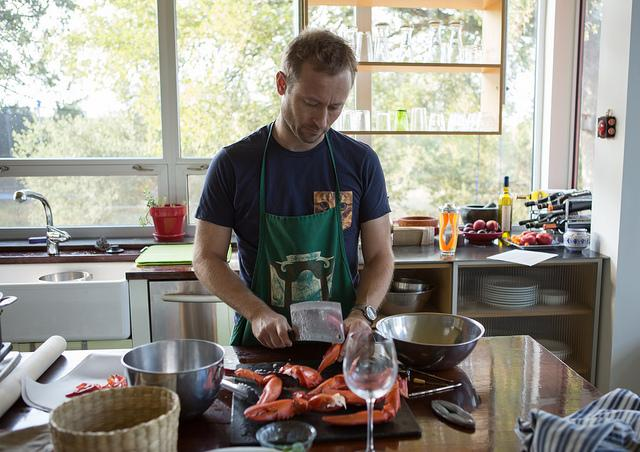What is the man in the apron cooking? lobster 